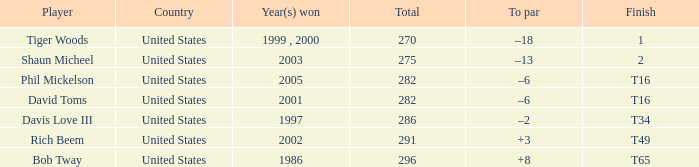In which year(s) did the person who has a total of 291 win? 2002.0. Parse the full table. {'header': ['Player', 'Country', 'Year(s) won', 'Total', 'To par', 'Finish'], 'rows': [['Tiger Woods', 'United States', '1999 , 2000', '270', '–18', '1'], ['Shaun Micheel', 'United States', '2003', '275', '–13', '2'], ['Phil Mickelson', 'United States', '2005', '282', '–6', 'T16'], ['David Toms', 'United States', '2001', '282', '–6', 'T16'], ['Davis Love III', 'United States', '1997', '286', '–2', 'T34'], ['Rich Beem', 'United States', '2002', '291', '+3', 'T49'], ['Bob Tway', 'United States', '1986', '296', '+8', 'T65']]} 